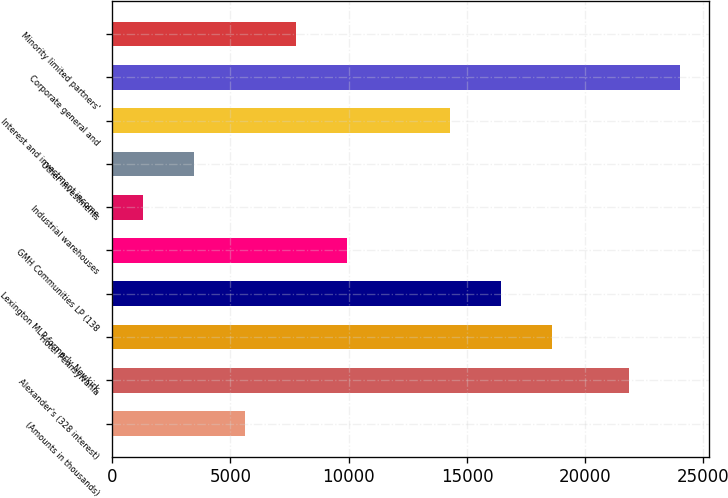Convert chart. <chart><loc_0><loc_0><loc_500><loc_500><bar_chart><fcel>(Amounts in thousands)<fcel>Alexander's (328 interest)<fcel>Hotel Pennsylvania<fcel>Lexington MLP formerly Newkirk<fcel>GMH Communities LP (138<fcel>Industrial warehouses<fcel>Other investments<fcel>Interest and investment income<fcel>Corporate general and<fcel>Minority limited partners'<nl><fcel>5612.2<fcel>21864<fcel>18590.8<fcel>16427.7<fcel>9938.4<fcel>1286<fcel>3449.1<fcel>14264.6<fcel>24027.1<fcel>7775.3<nl></chart> 